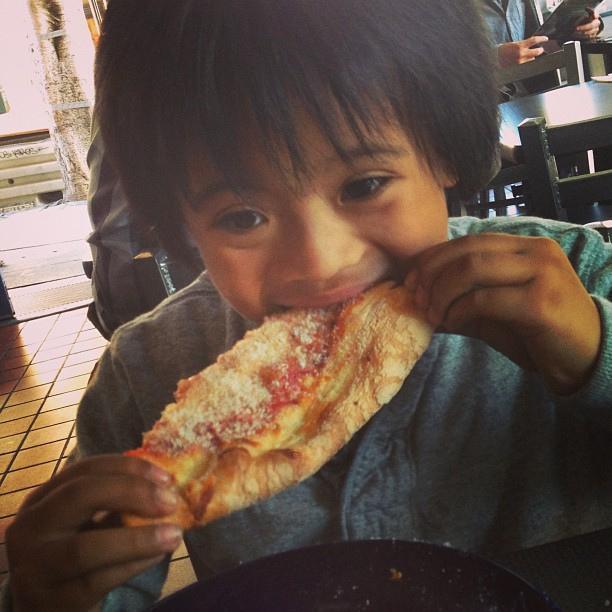How many dining tables are in the photo?
Give a very brief answer. 2. How many people are visible?
Give a very brief answer. 3. 